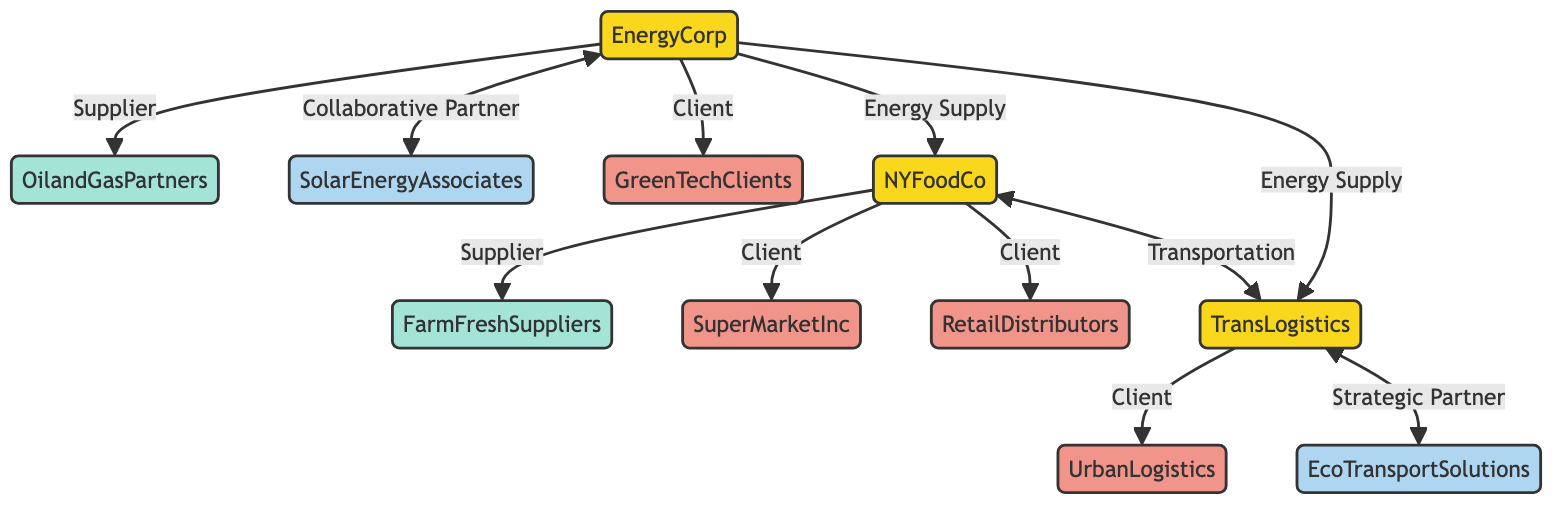What is the total number of nodes in the diagram? There are 11 nodes in the provided data: NYFoodCo, TransLogistics, EnergyCorp, FarmFreshSuppliers, SuperMarketInc, RetailDistributors, OilandGasPartners, SolarEnergyAssociates, EcoTransportSolutions, GreenTechClients, and UrbanLogistics.
Answer: 11 Which company is linked to UrbanLogistics? According to the diagram, TransLogistics is linked to UrbanLogistics as a client. The relationship specifically indicates that TransLogistics provides services to UrbanLogistics.
Answer: TransLogistics What type of relationship exists between EnergyCorp and SolarEnergyAssociates? The relationship between EnergyCorp and SolarEnergyAssociates is defined as a "Collaborative Partner," indicating a partnership aimed at mutual benefits rather than a supplier or client relationship.
Answer: Collaborative Partner How many clients does NYFoodCo have? NYFoodCo has two clients: SuperMarketInc and RetailDistributors, as indicated by the links directly connecting NYFoodCo to these entities with the "Client" relationship.
Answer: 2 Which company serves as a strategic partner to TransLogistics? EcoTransportSolutions is identified in the diagram as a strategic partner to TransLogistics, indicating a cooperative relationship aimed at enhancing transportation services.
Answer: EcoTransportSolutions What is the connection between EnergyCorp and NYFoodCo? EnergyCorp has an "Energy Supply" relationship with NYFoodCo, meaning that EnergyCorp supplies energy to NYFoodCo, which highlights an interdependence between these two companies.
Answer: Energy Supply What type of business does FarmFreshSuppliers represent? FarmFreshSuppliers is categorized as a "Food Supplier" in the diagram, indicating its role in the supply chain as a provider of raw materials for food production.
Answer: Food Supplier Which node has the most connections? EnergyCorp has the most connections, linking to five different entities (OilandGasPartners, SolarEnergyAssociates, GreenTechClients, NYFoodCo, and TransLogistics), showcasing its central role in the network.
Answer: EnergyCorp How many strategic partners are shown in the diagram? There is one strategic partner depicted in the diagram, which is EcoTransportSolutions, highlighting its role in the transportation network linked to TransLogistics.
Answer: 1 